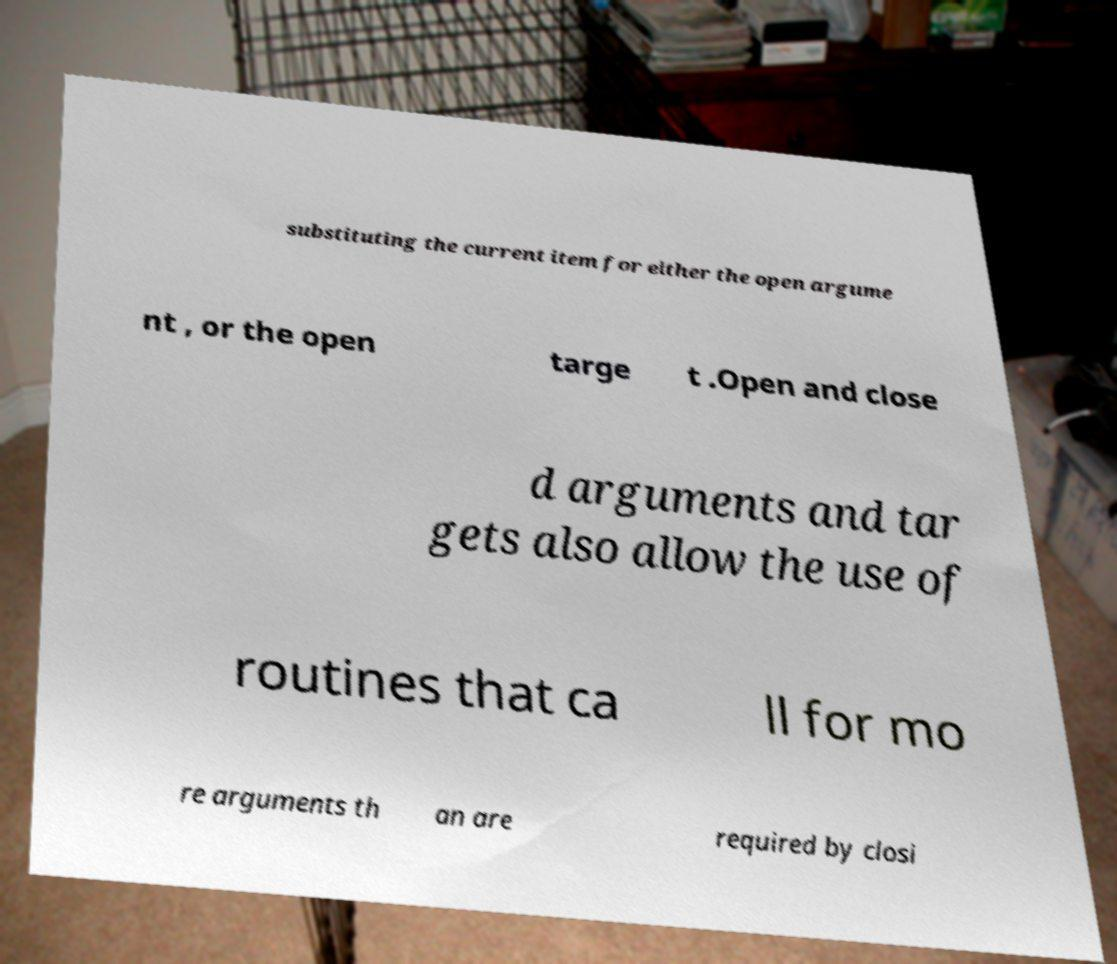Please identify and transcribe the text found in this image. substituting the current item for either the open argume nt , or the open targe t .Open and close d arguments and tar gets also allow the use of routines that ca ll for mo re arguments th an are required by closi 